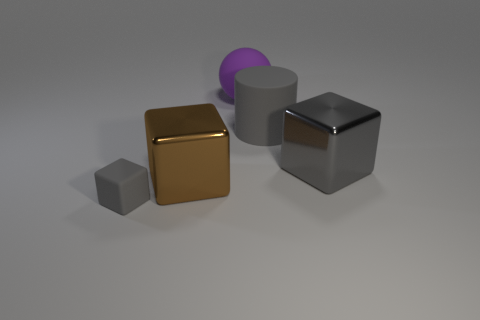Add 5 tiny brown shiny cylinders. How many objects exist? 10 Subtract all cylinders. How many objects are left? 4 Add 4 gray objects. How many gray objects are left? 7 Add 5 large gray cylinders. How many large gray cylinders exist? 6 Subtract 0 red blocks. How many objects are left? 5 Subtract all tiny gray things. Subtract all balls. How many objects are left? 3 